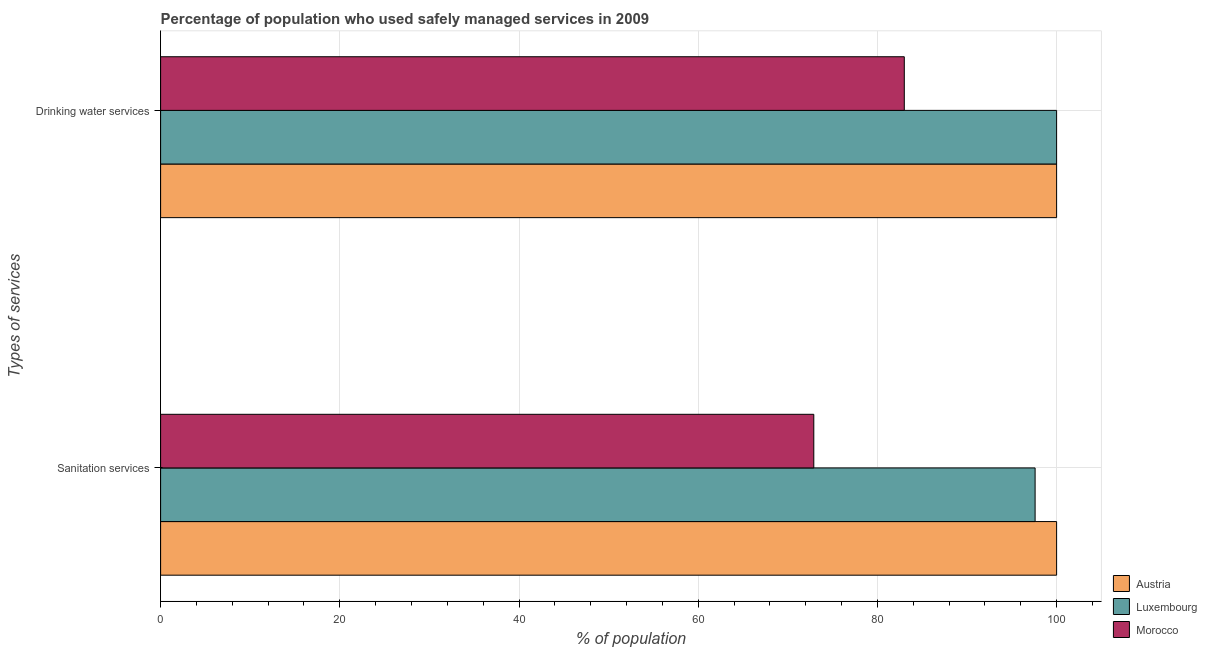How many different coloured bars are there?
Provide a short and direct response. 3. What is the label of the 1st group of bars from the top?
Your response must be concise. Drinking water services. What is the percentage of population who used sanitation services in Morocco?
Offer a very short reply. 72.9. Across all countries, what is the minimum percentage of population who used drinking water services?
Offer a very short reply. 83. In which country was the percentage of population who used sanitation services maximum?
Offer a terse response. Austria. In which country was the percentage of population who used drinking water services minimum?
Your answer should be very brief. Morocco. What is the total percentage of population who used drinking water services in the graph?
Ensure brevity in your answer.  283. What is the difference between the percentage of population who used sanitation services in Luxembourg and that in Morocco?
Ensure brevity in your answer.  24.7. What is the difference between the percentage of population who used sanitation services in Luxembourg and the percentage of population who used drinking water services in Austria?
Your answer should be very brief. -2.4. What is the average percentage of population who used drinking water services per country?
Ensure brevity in your answer.  94.33. What is the difference between the percentage of population who used drinking water services and percentage of population who used sanitation services in Luxembourg?
Your response must be concise. 2.4. What is the ratio of the percentage of population who used drinking water services in Austria to that in Luxembourg?
Keep it short and to the point. 1. Is the percentage of population who used drinking water services in Luxembourg less than that in Austria?
Your answer should be compact. No. What does the 2nd bar from the top in Sanitation services represents?
Provide a short and direct response. Luxembourg. What is the difference between two consecutive major ticks on the X-axis?
Provide a short and direct response. 20. Where does the legend appear in the graph?
Offer a very short reply. Bottom right. How many legend labels are there?
Your answer should be very brief. 3. What is the title of the graph?
Offer a very short reply. Percentage of population who used safely managed services in 2009. Does "Puerto Rico" appear as one of the legend labels in the graph?
Keep it short and to the point. No. What is the label or title of the X-axis?
Offer a very short reply. % of population. What is the label or title of the Y-axis?
Provide a short and direct response. Types of services. What is the % of population in Luxembourg in Sanitation services?
Keep it short and to the point. 97.6. What is the % of population in Morocco in Sanitation services?
Your answer should be very brief. 72.9. What is the % of population in Austria in Drinking water services?
Give a very brief answer. 100. What is the % of population of Morocco in Drinking water services?
Your answer should be very brief. 83. Across all Types of services, what is the maximum % of population of Austria?
Provide a short and direct response. 100. Across all Types of services, what is the maximum % of population of Morocco?
Your answer should be very brief. 83. Across all Types of services, what is the minimum % of population in Austria?
Keep it short and to the point. 100. Across all Types of services, what is the minimum % of population in Luxembourg?
Give a very brief answer. 97.6. Across all Types of services, what is the minimum % of population of Morocco?
Make the answer very short. 72.9. What is the total % of population in Luxembourg in the graph?
Offer a terse response. 197.6. What is the total % of population of Morocco in the graph?
Offer a terse response. 155.9. What is the difference between the % of population in Luxembourg in Sanitation services and that in Drinking water services?
Keep it short and to the point. -2.4. What is the difference between the % of population of Morocco in Sanitation services and that in Drinking water services?
Give a very brief answer. -10.1. What is the difference between the % of population in Austria in Sanitation services and the % of population in Luxembourg in Drinking water services?
Your response must be concise. 0. What is the difference between the % of population of Luxembourg in Sanitation services and the % of population of Morocco in Drinking water services?
Offer a very short reply. 14.6. What is the average % of population of Luxembourg per Types of services?
Your answer should be compact. 98.8. What is the average % of population of Morocco per Types of services?
Give a very brief answer. 77.95. What is the difference between the % of population in Austria and % of population in Luxembourg in Sanitation services?
Give a very brief answer. 2.4. What is the difference between the % of population of Austria and % of population of Morocco in Sanitation services?
Make the answer very short. 27.1. What is the difference between the % of population in Luxembourg and % of population in Morocco in Sanitation services?
Your response must be concise. 24.7. What is the difference between the % of population of Austria and % of population of Morocco in Drinking water services?
Your answer should be very brief. 17. What is the ratio of the % of population in Austria in Sanitation services to that in Drinking water services?
Your answer should be very brief. 1. What is the ratio of the % of population of Luxembourg in Sanitation services to that in Drinking water services?
Offer a terse response. 0.98. What is the ratio of the % of population of Morocco in Sanitation services to that in Drinking water services?
Offer a terse response. 0.88. What is the difference between the highest and the second highest % of population of Luxembourg?
Your answer should be compact. 2.4. What is the difference between the highest and the second highest % of population in Morocco?
Ensure brevity in your answer.  10.1. What is the difference between the highest and the lowest % of population in Luxembourg?
Make the answer very short. 2.4. 